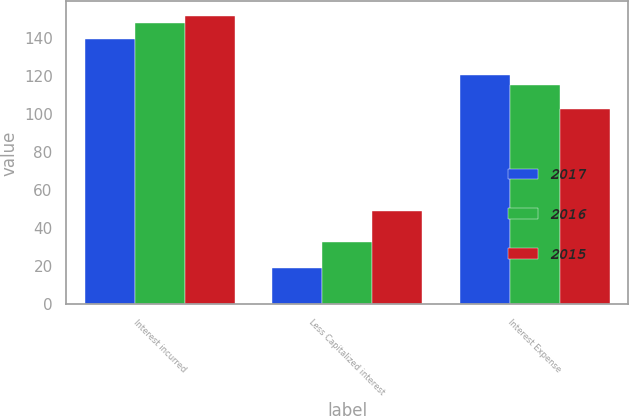Convert chart to OTSL. <chart><loc_0><loc_0><loc_500><loc_500><stacked_bar_chart><ecel><fcel>Interest incurred<fcel>Less Capitalized interest<fcel>Interest Expense<nl><fcel>2017<fcel>139.6<fcel>19<fcel>120.6<nl><fcel>2016<fcel>147.9<fcel>32.7<fcel>115.2<nl><fcel>2015<fcel>151.9<fcel>49.1<fcel>102.8<nl></chart> 